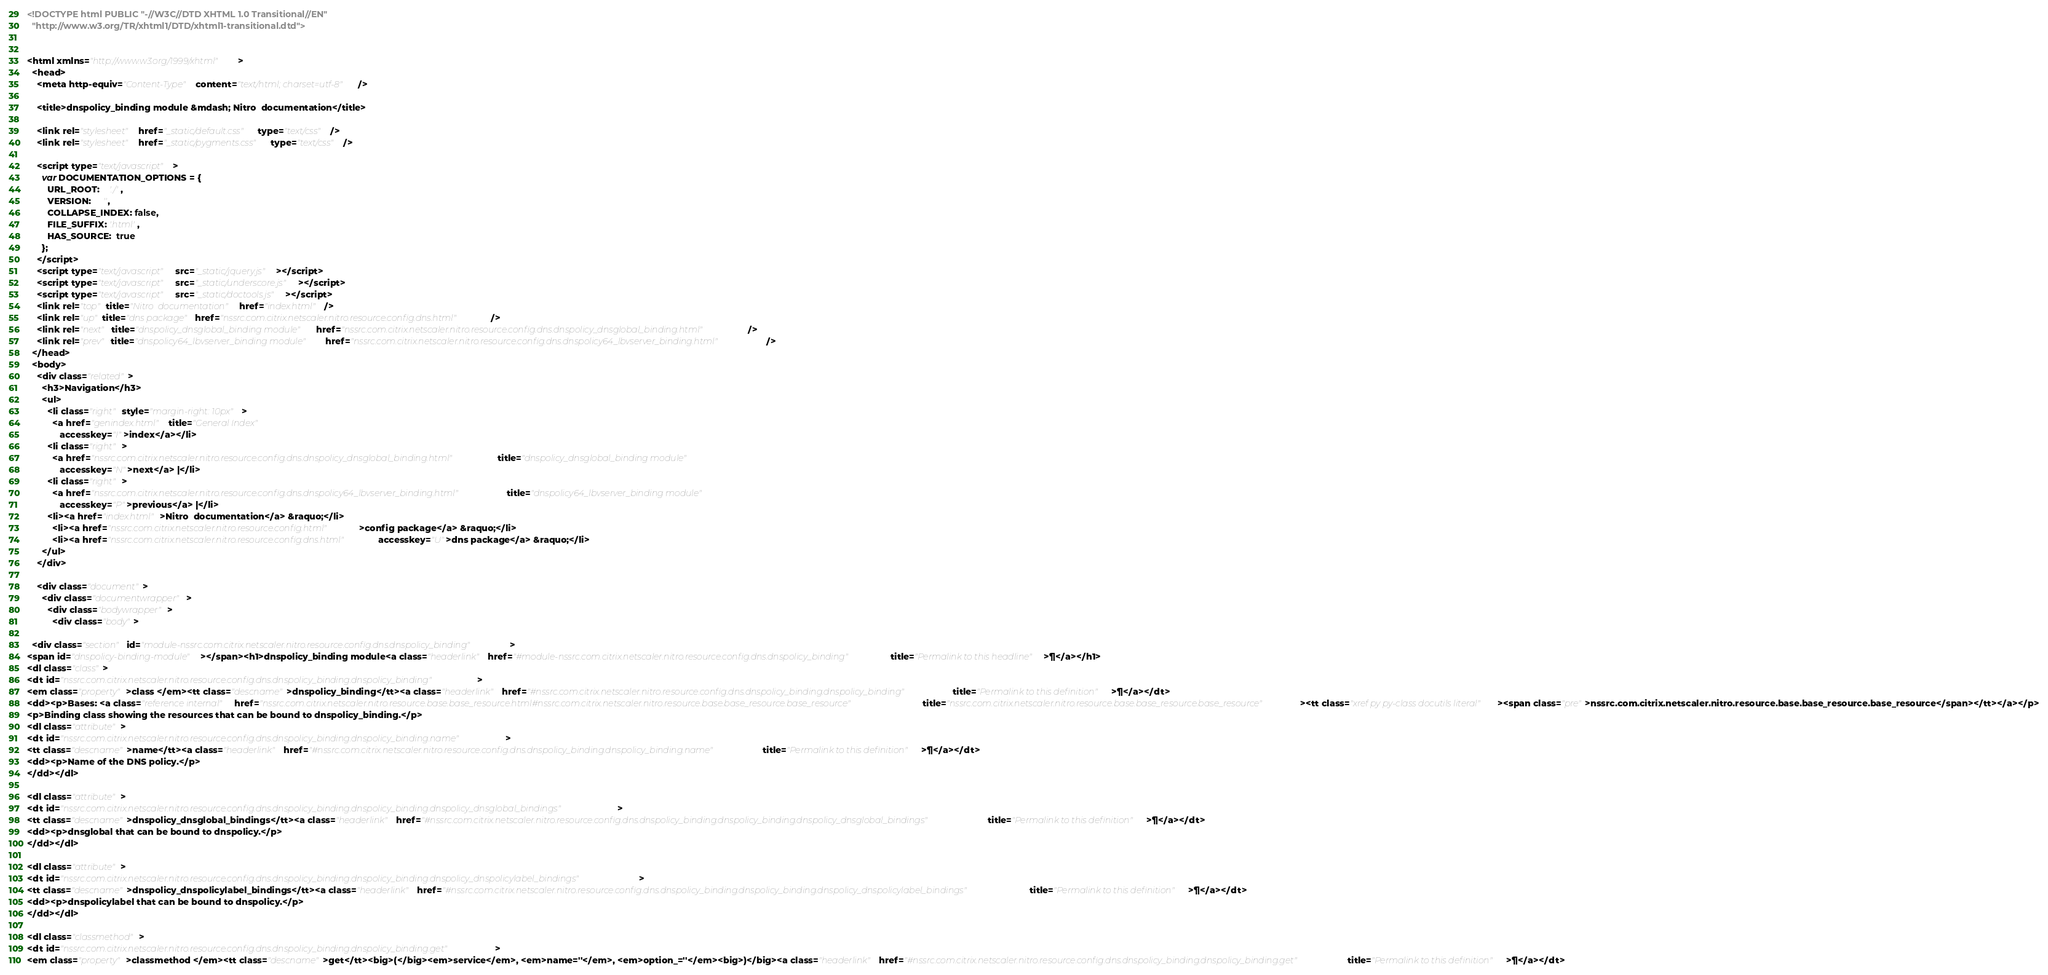Convert code to text. <code><loc_0><loc_0><loc_500><loc_500><_HTML_><!DOCTYPE html PUBLIC "-//W3C//DTD XHTML 1.0 Transitional//EN"
  "http://www.w3.org/TR/xhtml1/DTD/xhtml1-transitional.dtd">


<html xmlns="http://www.w3.org/1999/xhtml">
  <head>
    <meta http-equiv="Content-Type" content="text/html; charset=utf-8" />
    
    <title>dnspolicy_binding module &mdash; Nitro  documentation</title>
    
    <link rel="stylesheet" href="_static/default.css" type="text/css" />
    <link rel="stylesheet" href="_static/pygments.css" type="text/css" />
    
    <script type="text/javascript">
      var DOCUMENTATION_OPTIONS = {
        URL_ROOT:    './',
        VERSION:     '',
        COLLAPSE_INDEX: false,
        FILE_SUFFIX: '.html',
        HAS_SOURCE:  true
      };
    </script>
    <script type="text/javascript" src="_static/jquery.js"></script>
    <script type="text/javascript" src="_static/underscore.js"></script>
    <script type="text/javascript" src="_static/doctools.js"></script>
    <link rel="top" title="Nitro  documentation" href="index.html" />
    <link rel="up" title="dns package" href="nssrc.com.citrix.netscaler.nitro.resource.config.dns.html" />
    <link rel="next" title="dnspolicy_dnsglobal_binding module" href="nssrc.com.citrix.netscaler.nitro.resource.config.dns.dnspolicy_dnsglobal_binding.html" />
    <link rel="prev" title="dnspolicy64_lbvserver_binding module" href="nssrc.com.citrix.netscaler.nitro.resource.config.dns.dnspolicy64_lbvserver_binding.html" /> 
  </head>
  <body>
    <div class="related">
      <h3>Navigation</h3>
      <ul>
        <li class="right" style="margin-right: 10px">
          <a href="genindex.html" title="General Index"
             accesskey="I">index</a></li>
        <li class="right" >
          <a href="nssrc.com.citrix.netscaler.nitro.resource.config.dns.dnspolicy_dnsglobal_binding.html" title="dnspolicy_dnsglobal_binding module"
             accesskey="N">next</a> |</li>
        <li class="right" >
          <a href="nssrc.com.citrix.netscaler.nitro.resource.config.dns.dnspolicy64_lbvserver_binding.html" title="dnspolicy64_lbvserver_binding module"
             accesskey="P">previous</a> |</li>
        <li><a href="index.html">Nitro  documentation</a> &raquo;</li>
          <li><a href="nssrc.com.citrix.netscaler.nitro.resource.config.html" >config package</a> &raquo;</li>
          <li><a href="nssrc.com.citrix.netscaler.nitro.resource.config.dns.html" accesskey="U">dns package</a> &raquo;</li> 
      </ul>
    </div>  

    <div class="document">
      <div class="documentwrapper">
        <div class="bodywrapper">
          <div class="body">
            
  <div class="section" id="module-nssrc.com.citrix.netscaler.nitro.resource.config.dns.dnspolicy_binding">
<span id="dnspolicy-binding-module"></span><h1>dnspolicy_binding module<a class="headerlink" href="#module-nssrc.com.citrix.netscaler.nitro.resource.config.dns.dnspolicy_binding" title="Permalink to this headline">¶</a></h1>
<dl class="class">
<dt id="nssrc.com.citrix.netscaler.nitro.resource.config.dns.dnspolicy_binding.dnspolicy_binding">
<em class="property">class </em><tt class="descname">dnspolicy_binding</tt><a class="headerlink" href="#nssrc.com.citrix.netscaler.nitro.resource.config.dns.dnspolicy_binding.dnspolicy_binding" title="Permalink to this definition">¶</a></dt>
<dd><p>Bases: <a class="reference internal" href="nssrc.com.citrix.netscaler.nitro.resource.base.base_resource.html#nssrc.com.citrix.netscaler.nitro.resource.base.base_resource.base_resource" title="nssrc.com.citrix.netscaler.nitro.resource.base.base_resource.base_resource"><tt class="xref py py-class docutils literal"><span class="pre">nssrc.com.citrix.netscaler.nitro.resource.base.base_resource.base_resource</span></tt></a></p>
<p>Binding class showing the resources that can be bound to dnspolicy_binding.</p>
<dl class="attribute">
<dt id="nssrc.com.citrix.netscaler.nitro.resource.config.dns.dnspolicy_binding.dnspolicy_binding.name">
<tt class="descname">name</tt><a class="headerlink" href="#nssrc.com.citrix.netscaler.nitro.resource.config.dns.dnspolicy_binding.dnspolicy_binding.name" title="Permalink to this definition">¶</a></dt>
<dd><p>Name of the DNS policy.</p>
</dd></dl>

<dl class="attribute">
<dt id="nssrc.com.citrix.netscaler.nitro.resource.config.dns.dnspolicy_binding.dnspolicy_binding.dnspolicy_dnsglobal_bindings">
<tt class="descname">dnspolicy_dnsglobal_bindings</tt><a class="headerlink" href="#nssrc.com.citrix.netscaler.nitro.resource.config.dns.dnspolicy_binding.dnspolicy_binding.dnspolicy_dnsglobal_bindings" title="Permalink to this definition">¶</a></dt>
<dd><p>dnsglobal that can be bound to dnspolicy.</p>
</dd></dl>

<dl class="attribute">
<dt id="nssrc.com.citrix.netscaler.nitro.resource.config.dns.dnspolicy_binding.dnspolicy_binding.dnspolicy_dnspolicylabel_bindings">
<tt class="descname">dnspolicy_dnspolicylabel_bindings</tt><a class="headerlink" href="#nssrc.com.citrix.netscaler.nitro.resource.config.dns.dnspolicy_binding.dnspolicy_binding.dnspolicy_dnspolicylabel_bindings" title="Permalink to this definition">¶</a></dt>
<dd><p>dnspolicylabel that can be bound to dnspolicy.</p>
</dd></dl>

<dl class="classmethod">
<dt id="nssrc.com.citrix.netscaler.nitro.resource.config.dns.dnspolicy_binding.dnspolicy_binding.get">
<em class="property">classmethod </em><tt class="descname">get</tt><big>(</big><em>service</em>, <em>name=''</em>, <em>option_=''</em><big>)</big><a class="headerlink" href="#nssrc.com.citrix.netscaler.nitro.resource.config.dns.dnspolicy_binding.dnspolicy_binding.get" title="Permalink to this definition">¶</a></dt></code> 